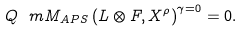<formula> <loc_0><loc_0><loc_500><loc_500>Q ^ { \ } m M _ { A P S } \left ( L \otimes F , X ^ { \rho } \right ) ^ { \gamma = 0 } = 0 .</formula> 